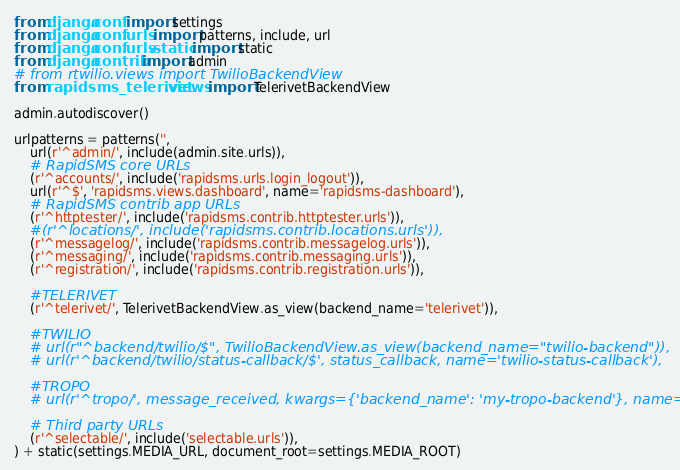Convert code to text. <code><loc_0><loc_0><loc_500><loc_500><_Python_>from django.conf import settings
from django.conf.urls import patterns, include, url
from django.conf.urls.static import static
from django.contrib import admin
# from rtwilio.views import TwilioBackendView
from rapidsms_telerivet.views import TelerivetBackendView

admin.autodiscover()

urlpatterns = patterns('',
    url(r'^admin/', include(admin.site.urls)),
    # RapidSMS core URLs
    (r'^accounts/', include('rapidsms.urls.login_logout')),
    url(r'^$', 'rapidsms.views.dashboard', name='rapidsms-dashboard'),
    # RapidSMS contrib app URLs
    (r'^httptester/', include('rapidsms.contrib.httptester.urls')),
    #(r'^locations/', include('rapidsms.contrib.locations.urls')),
    (r'^messagelog/', include('rapidsms.contrib.messagelog.urls')),
    (r'^messaging/', include('rapidsms.contrib.messaging.urls')),
    (r'^registration/', include('rapidsms.contrib.registration.urls')),

    #TELERIVET
    (r'^telerivet/', TelerivetBackendView.as_view(backend_name='telerivet')),

    #TWILIO
    # url(r"^backend/twilio/$", TwilioBackendView.as_view(backend_name="twilio-backend")),
    # url(r'^backend/twilio/status-callback/$', status_callback, name='twilio-status-callback'),

    #TROPO
    # url(r'^tropo/', message_received, kwargs={'backend_name': 'my-tropo-backend'}, name='tropo'),

    # Third party URLs
    (r'^selectable/', include('selectable.urls')),
) + static(settings.MEDIA_URL, document_root=settings.MEDIA_ROOT)
</code> 